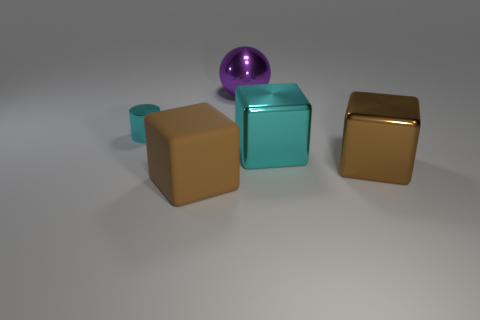How many objects are metal things that are in front of the tiny object or small green spheres?
Make the answer very short. 2. How many other objects are there of the same shape as the small cyan metal thing?
Your response must be concise. 0. Are there more brown cubes to the right of the purple shiny thing than large purple blocks?
Keep it short and to the point. Yes. The rubber thing that is the same shape as the brown metal object is what size?
Offer a terse response. Large. What is the shape of the big purple thing?
Give a very brief answer. Sphere. What shape is the brown shiny object that is the same size as the rubber thing?
Provide a short and direct response. Cube. Is there any other thing that is the same color as the tiny shiny thing?
Make the answer very short. Yes. The purple sphere that is made of the same material as the small thing is what size?
Offer a very short reply. Large. Is the shape of the big matte thing the same as the brown thing on the right side of the big purple ball?
Make the answer very short. Yes. How big is the cyan shiny cylinder?
Give a very brief answer. Small. 